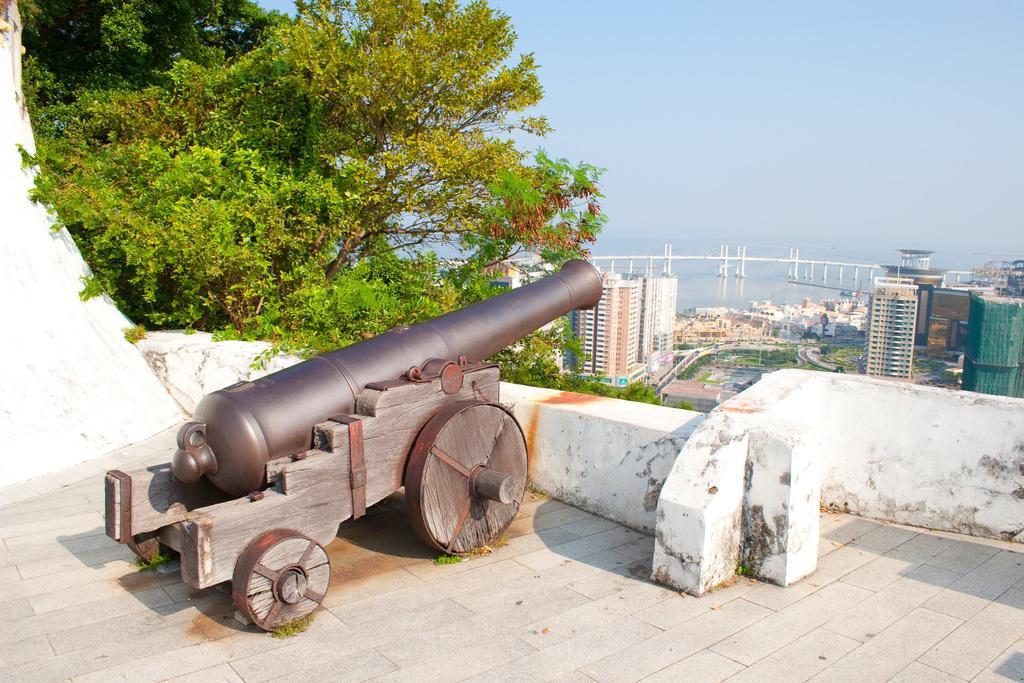Please provide a concise description of this image. In this image we can see a cannon. Behind the cannon we can see a wall, trees and buildings. In the background, we can see a bridge and the water. At the top we can see the sky. 